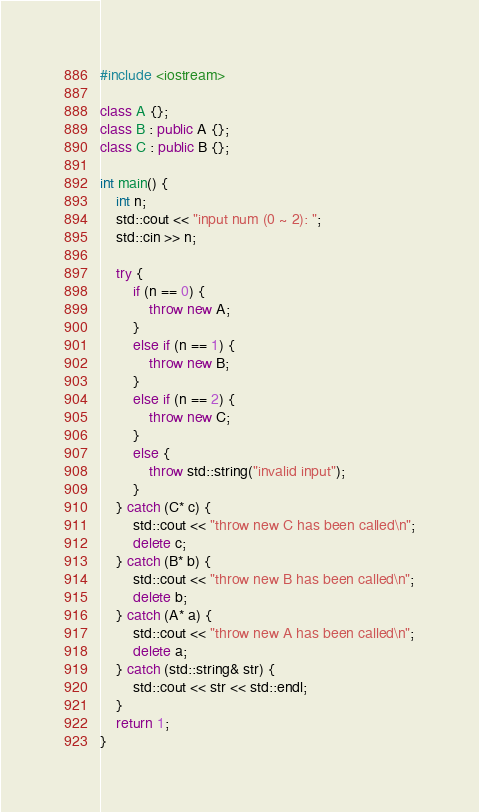Convert code to text. <code><loc_0><loc_0><loc_500><loc_500><_C++_>#include <iostream>

class A {};
class B : public A {};
class C : public B {};

int main() {
    int n;
    std::cout << "input num (0 ~ 2): ";
    std::cin >> n;

    try {
        if (n == 0) {
            throw new A;
        }
        else if (n == 1) {
            throw new B;
        }
        else if (n == 2) {
            throw new C;
        }
        else {
            throw std::string("invalid input");
        }
    } catch (C* c) {
        std::cout << "throw new C has been called\n";
        delete c;
    } catch (B* b) {
        std::cout << "throw new B has been called\n";
        delete b;
    } catch (A* a) {
        std::cout << "throw new A has been called\n";
        delete a;
    } catch (std::string& str) {
        std::cout << str << std::endl;
    }
    return 1;
}</code> 